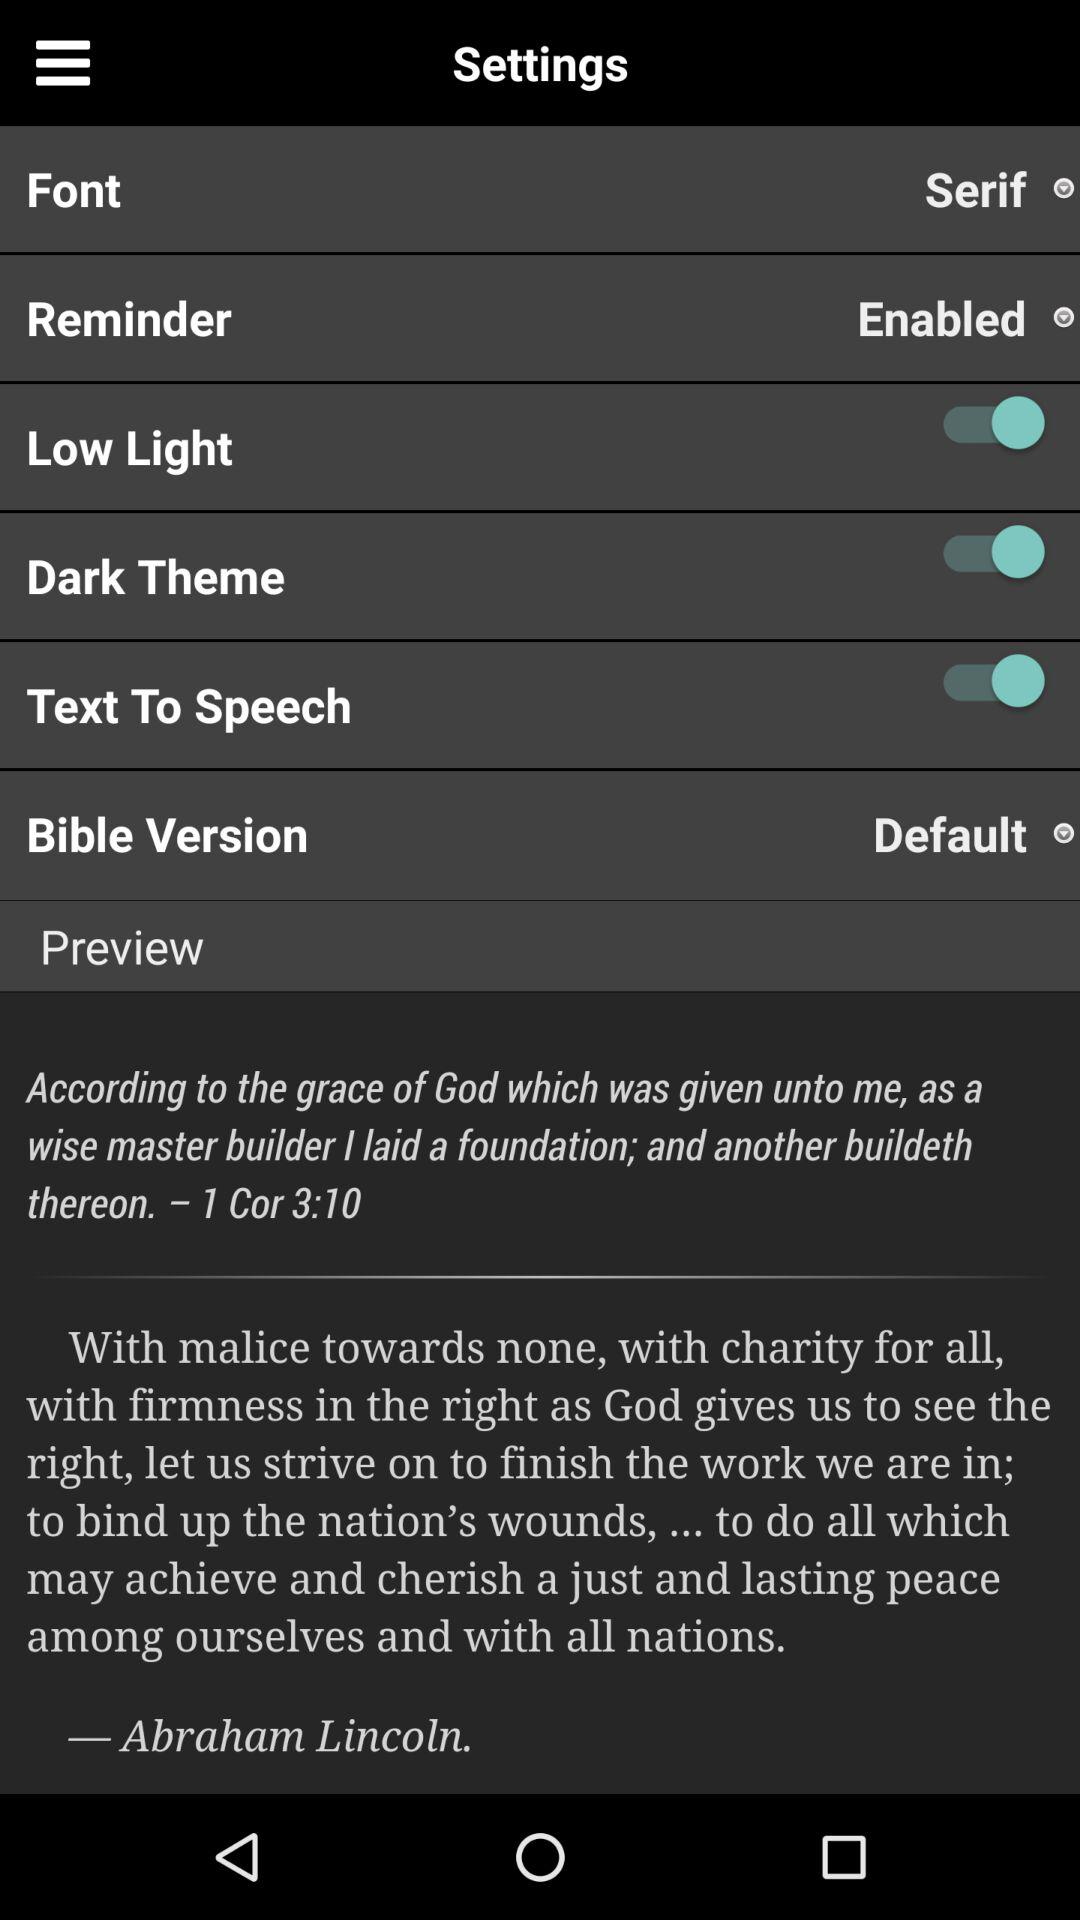What is the status for the reminder? The status is enabled. 